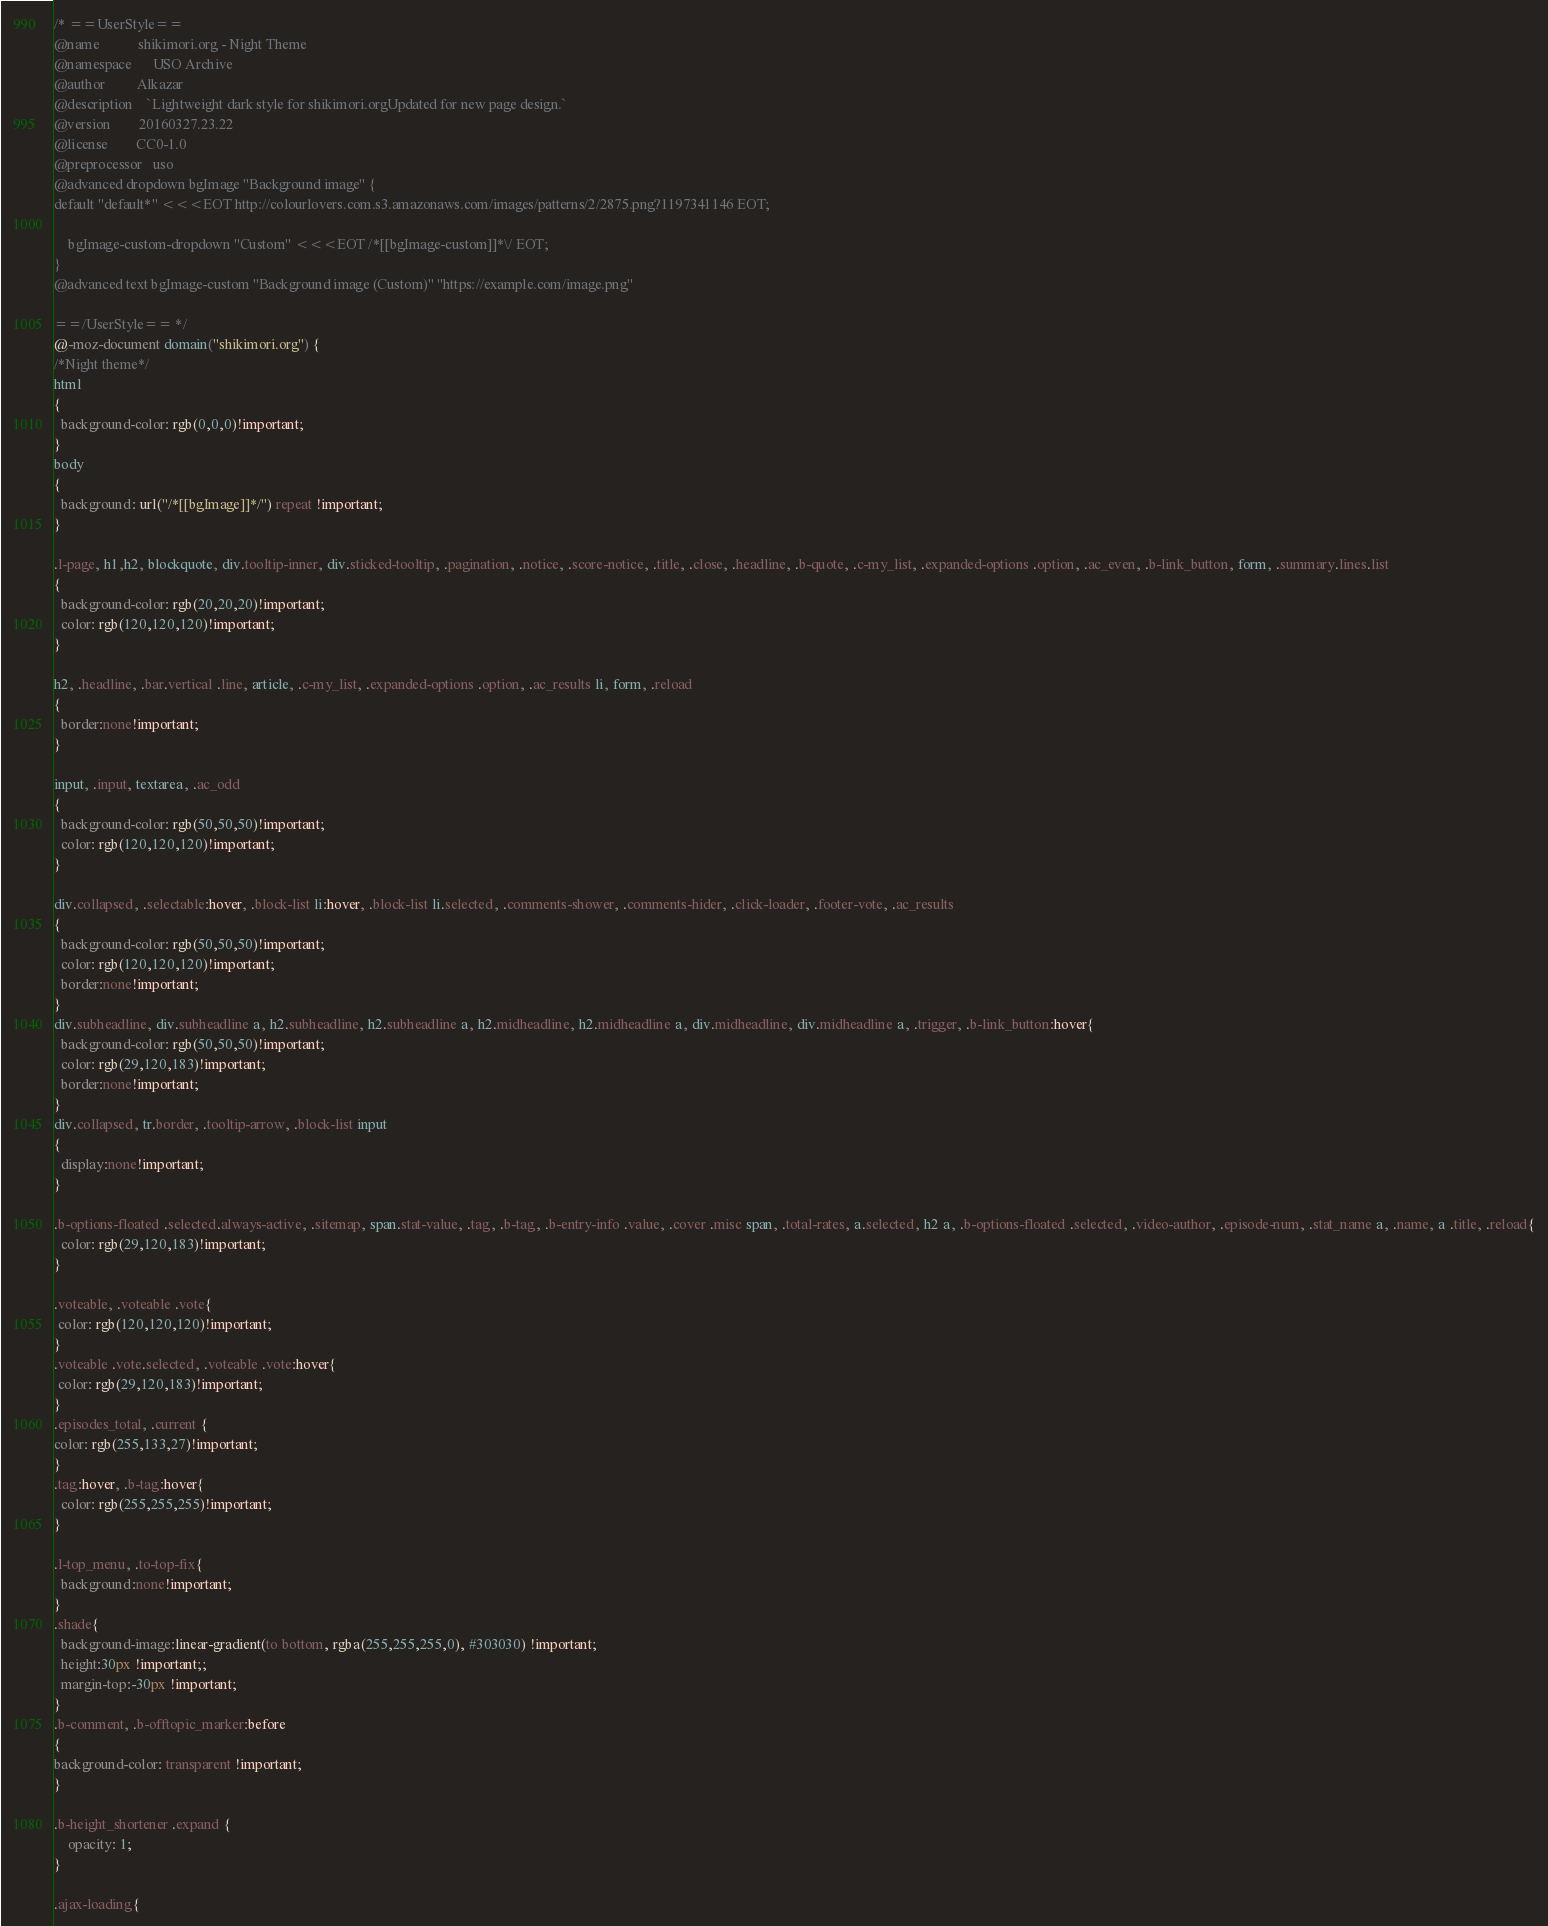Convert code to text. <code><loc_0><loc_0><loc_500><loc_500><_CSS_>/* ==UserStyle==
@name           shikimori.org - Night Theme
@namespace      USO Archive
@author         Alkazar
@description    `Lightweight dark style for shikimori.orgUpdated for new page design.`
@version        20160327.23.22
@license        CC0-1.0
@preprocessor   uso
@advanced dropdown bgImage "Background image" {
default "default*" <<<EOT http://colourlovers.com.s3.amazonaws.com/images/patterns/2/2875.png?1197341146 EOT;

	bgImage-custom-dropdown "Custom" <<<EOT /*[[bgImage-custom]]*\/ EOT;
}
@advanced text bgImage-custom "Background image (Custom)" "https://example.com/image.png"

==/UserStyle== */
@-moz-document domain("shikimori.org") {
/*Night theme*/
html
{  
  background-color: rgb(0,0,0)!important;
}
body 
{ 
  background: url("/*[[bgImage]]*/") repeat !important;   
}

.l-page, h1,h2, blockquote, div.tooltip-inner, div.sticked-tooltip, .pagination, .notice, .score-notice, .title, .close, .headline, .b-quote, .c-my_list, .expanded-options .option, .ac_even, .b-link_button, form, .summary.lines.list
{  
  background-color: rgb(20,20,20)!important;
  color: rgb(120,120,120)!important;
}

h2, .headline, .bar.vertical .line, article, .c-my_list, .expanded-options .option, .ac_results li, form, .reload
{  
  border:none!important;
}

input, .input, textarea, .ac_odd
{  
  background-color: rgb(50,50,50)!important;
  color: rgb(120,120,120)!important;
}

div.collapsed, .selectable:hover, .block-list li:hover, .block-list li.selected, .comments-shower, .comments-hider, .click-loader, .footer-vote, .ac_results
{  
  background-color: rgb(50,50,50)!important;
  color: rgb(120,120,120)!important;
  border:none!important;
}
div.subheadline, div.subheadline a, h2.subheadline, h2.subheadline a, h2.midheadline, h2.midheadline a, div.midheadline, div.midheadline a, .trigger, .b-link_button:hover{  
  background-color: rgb(50,50,50)!important;
  color: rgb(29,120,183)!important;
  border:none!important;
}
div.collapsed, tr.border, .tooltip-arrow, .block-list input
{  
  display:none!important;
}

.b-options-floated .selected.always-active, .sitemap, span.stat-value, .tag, .b-tag, .b-entry-info .value, .cover .misc span, .total-rates, a.selected, h2 a, .b-options-floated .selected, .video-author, .episode-num, .stat_name a, .name, a .title, .reload{
  color: rgb(29,120,183)!important;
}

.voteable, .voteable .vote{
 color: rgb(120,120,120)!important;
}   
.voteable .vote.selected, .voteable .vote:hover{
 color: rgb(29,120,183)!important;
} 
.episodes_total, .current {
color: rgb(255,133,27)!important;
}
.tag:hover, .b-tag:hover{
  color: rgb(255,255,255)!important;
}   

.l-top_menu, .to-top-fix{
  background:none!important;
}
.shade{
  background-image:linear-gradient(to bottom, rgba(255,255,255,0), #303030) !important;
  height:30px !important;;
  margin-top:-30px !important;
}
.b-comment, .b-offtopic_marker:before
{
background-color: transparent !important;
}

.b-height_shortener .expand {
	opacity: 1;
}
    
.ajax-loading{</code> 